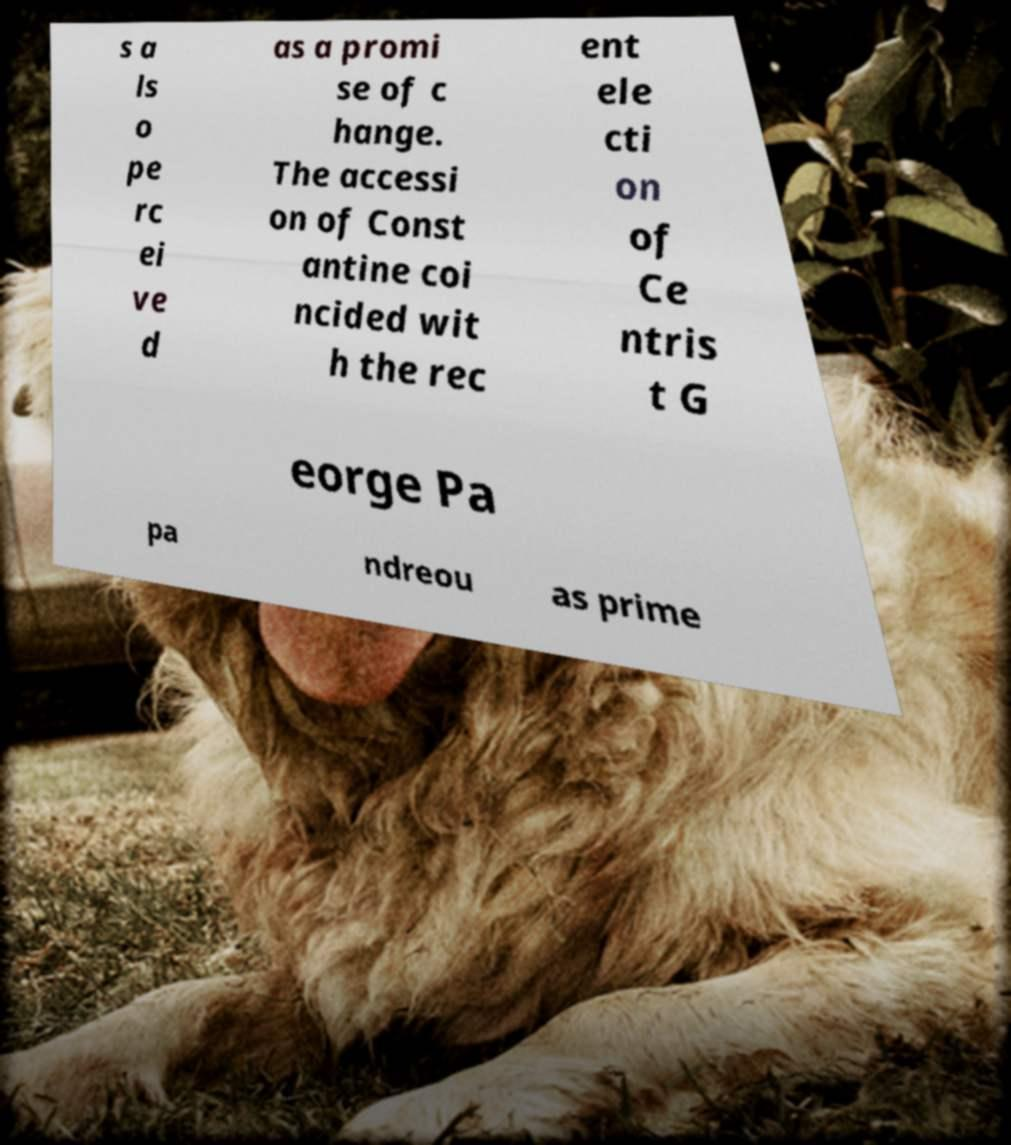What messages or text are displayed in this image? I need them in a readable, typed format. s a ls o pe rc ei ve d as a promi se of c hange. The accessi on of Const antine coi ncided wit h the rec ent ele cti on of Ce ntris t G eorge Pa pa ndreou as prime 